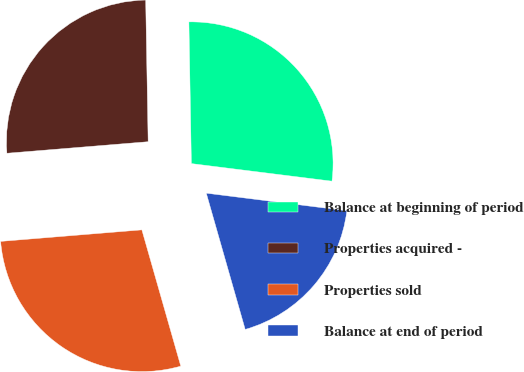Convert chart. <chart><loc_0><loc_0><loc_500><loc_500><pie_chart><fcel>Balance at beginning of period<fcel>Properties acquired -<fcel>Properties sold<fcel>Balance at end of period<nl><fcel>27.26%<fcel>26.02%<fcel>28.13%<fcel>18.59%<nl></chart> 